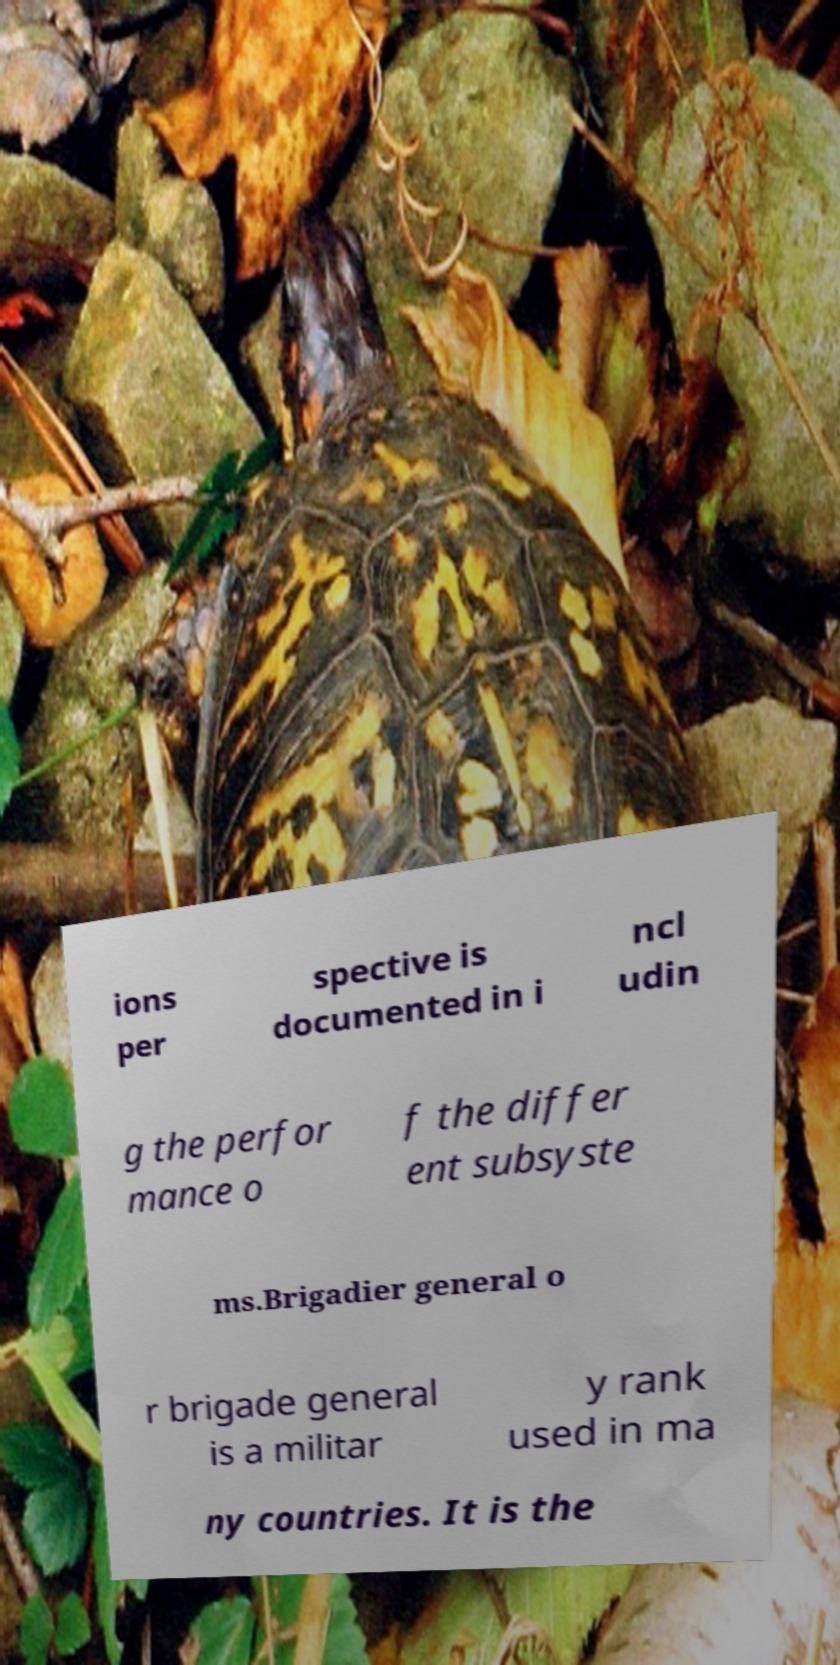What messages or text are displayed in this image? I need them in a readable, typed format. ions per spective is documented in i ncl udin g the perfor mance o f the differ ent subsyste ms.Brigadier general o r brigade general is a militar y rank used in ma ny countries. It is the 